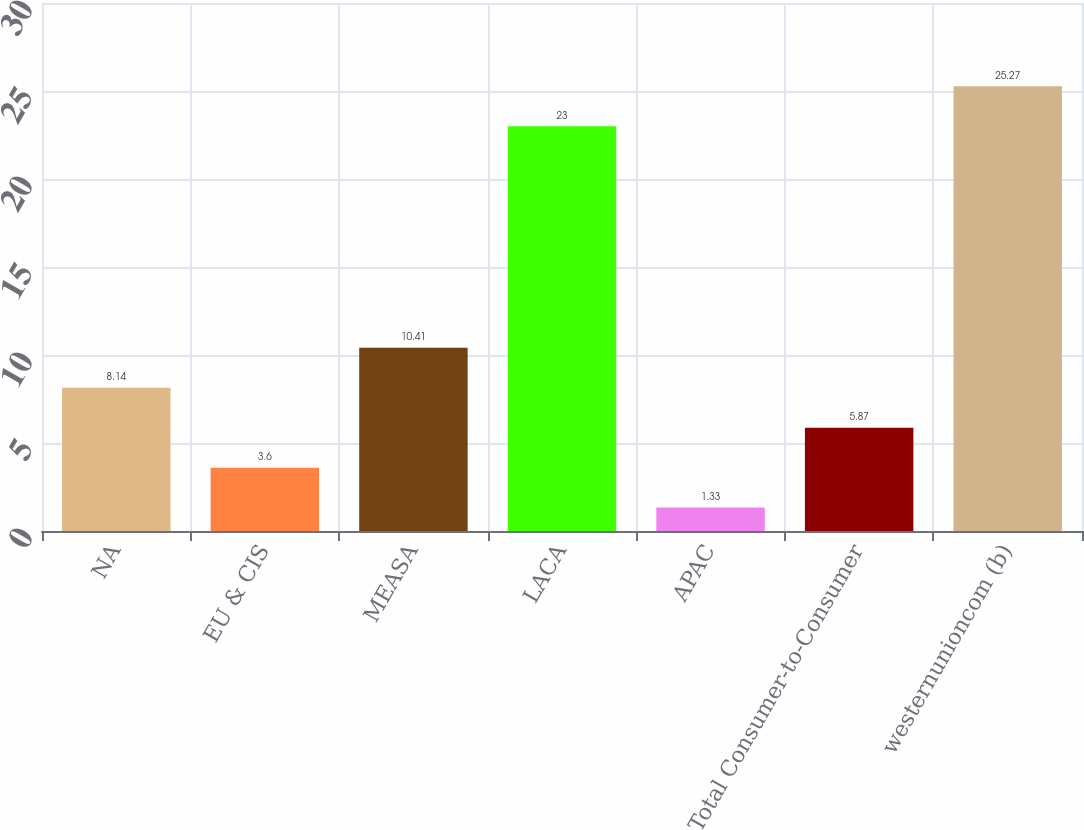Convert chart to OTSL. <chart><loc_0><loc_0><loc_500><loc_500><bar_chart><fcel>NA<fcel>EU & CIS<fcel>MEASA<fcel>LACA<fcel>APAC<fcel>Total Consumer-to-Consumer<fcel>westernunioncom (b)<nl><fcel>8.14<fcel>3.6<fcel>10.41<fcel>23<fcel>1.33<fcel>5.87<fcel>25.27<nl></chart> 